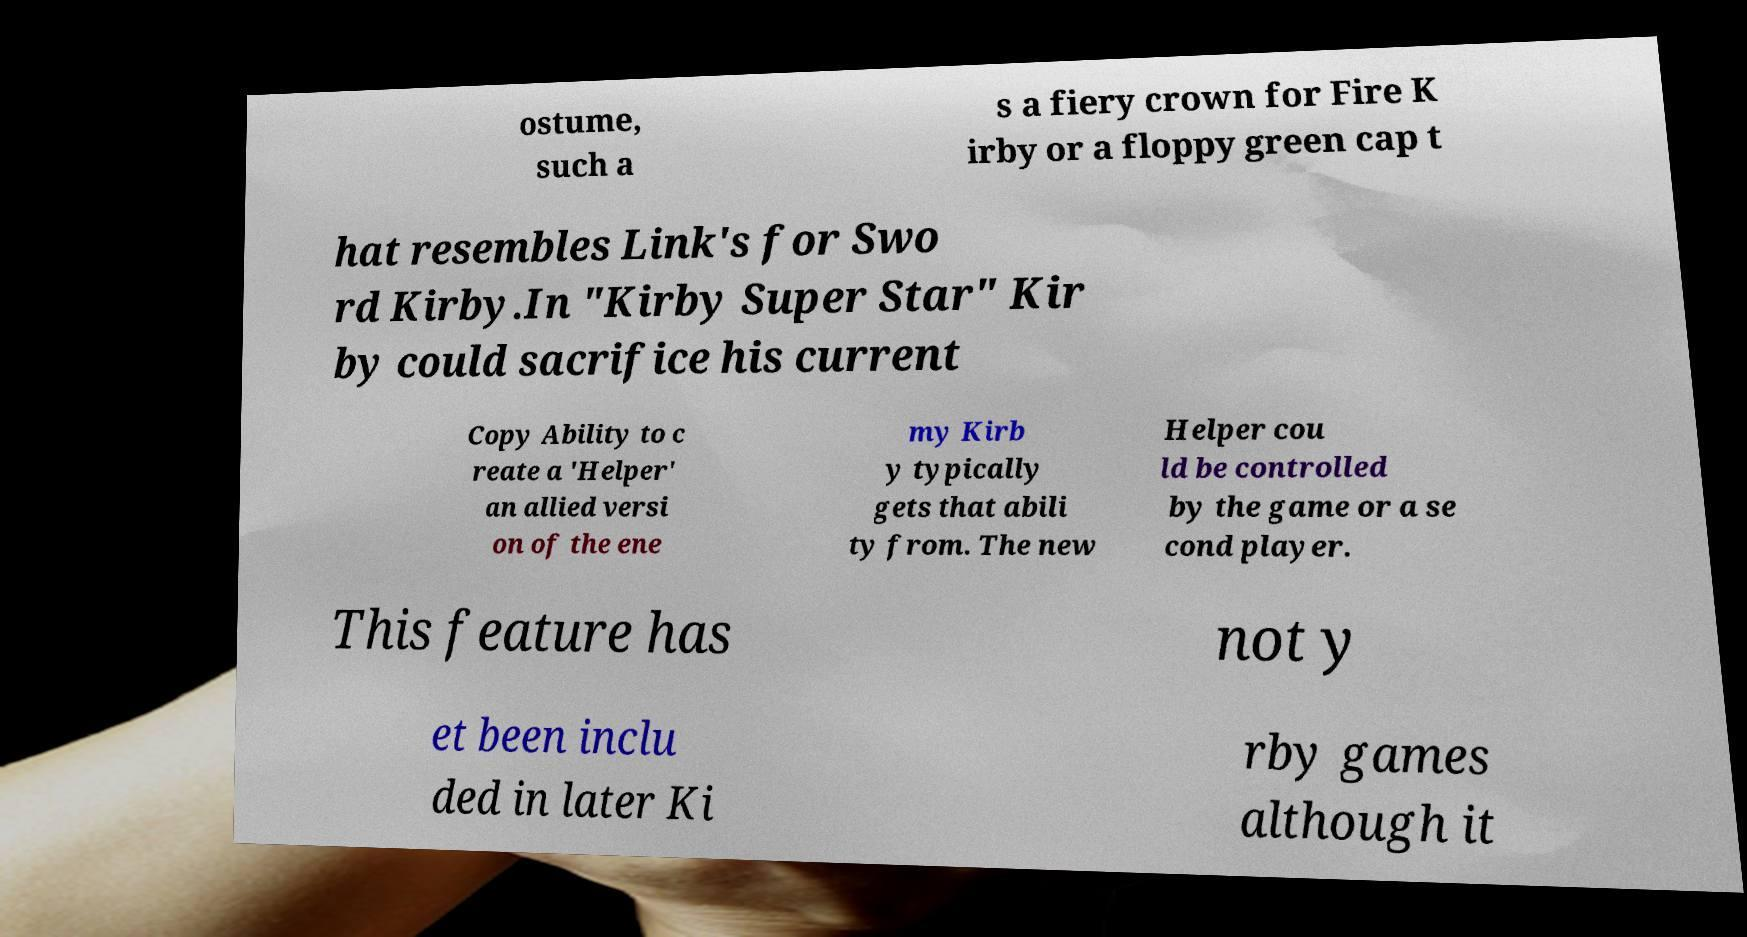I need the written content from this picture converted into text. Can you do that? ostume, such a s a fiery crown for Fire K irby or a floppy green cap t hat resembles Link's for Swo rd Kirby.In "Kirby Super Star" Kir by could sacrifice his current Copy Ability to c reate a 'Helper' an allied versi on of the ene my Kirb y typically gets that abili ty from. The new Helper cou ld be controlled by the game or a se cond player. This feature has not y et been inclu ded in later Ki rby games although it 